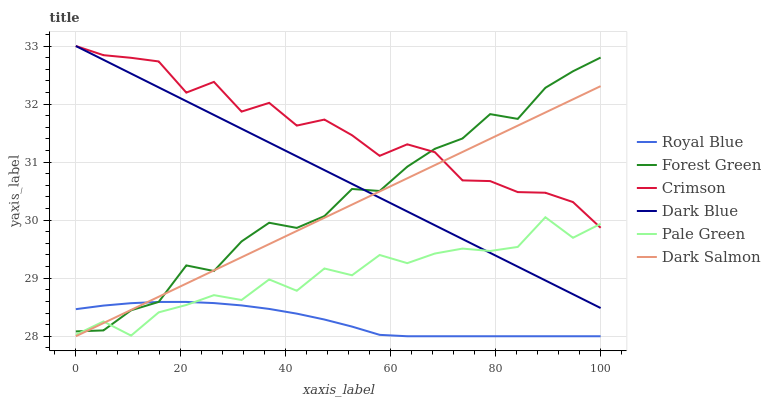Does Royal Blue have the minimum area under the curve?
Answer yes or no. Yes. Does Crimson have the maximum area under the curve?
Answer yes or no. Yes. Does Dark Salmon have the minimum area under the curve?
Answer yes or no. No. Does Dark Salmon have the maximum area under the curve?
Answer yes or no. No. Is Dark Blue the smoothest?
Answer yes or no. Yes. Is Pale Green the roughest?
Answer yes or no. Yes. Is Dark Salmon the smoothest?
Answer yes or no. No. Is Dark Salmon the roughest?
Answer yes or no. No. Does Dark Salmon have the lowest value?
Answer yes or no. Yes. Does Forest Green have the lowest value?
Answer yes or no. No. Does Crimson have the highest value?
Answer yes or no. Yes. Does Dark Salmon have the highest value?
Answer yes or no. No. Is Royal Blue less than Crimson?
Answer yes or no. Yes. Is Crimson greater than Royal Blue?
Answer yes or no. Yes. Does Royal Blue intersect Dark Salmon?
Answer yes or no. Yes. Is Royal Blue less than Dark Salmon?
Answer yes or no. No. Is Royal Blue greater than Dark Salmon?
Answer yes or no. No. Does Royal Blue intersect Crimson?
Answer yes or no. No. 